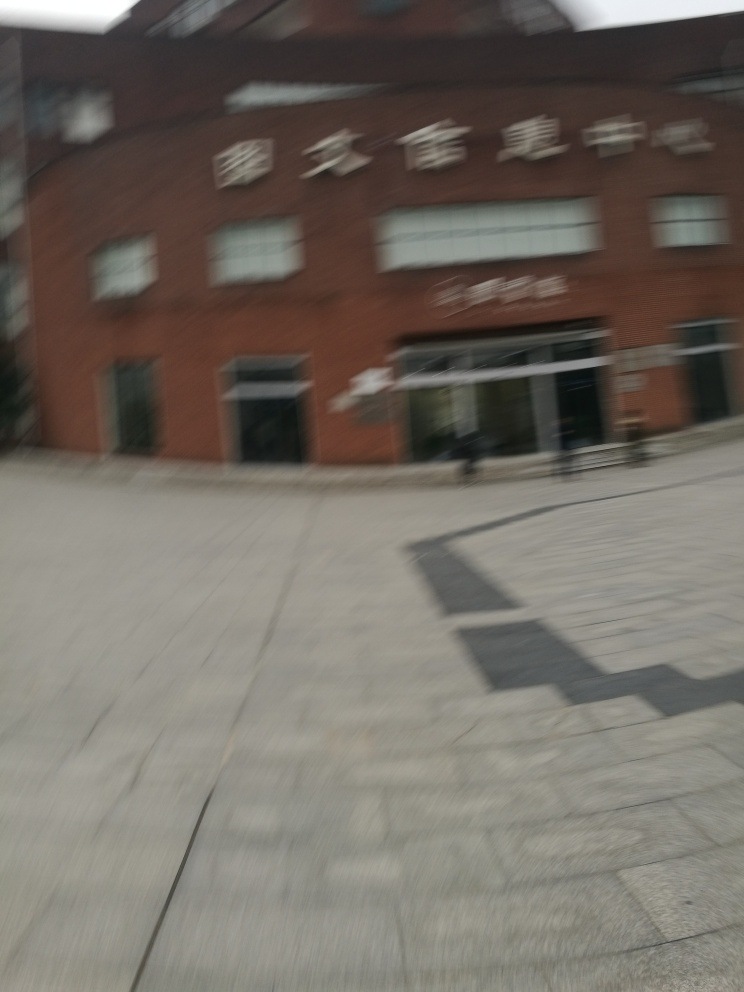What kind of establishment is shown in this image? The image appears to show a building with signage that suggests it is a commercial establishment. Due to the motion blur, the specific nature of the business cannot be confidently identified. 